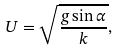<formula> <loc_0><loc_0><loc_500><loc_500>U = \sqrt { \frac { g \sin \alpha } { k } } ,</formula> 